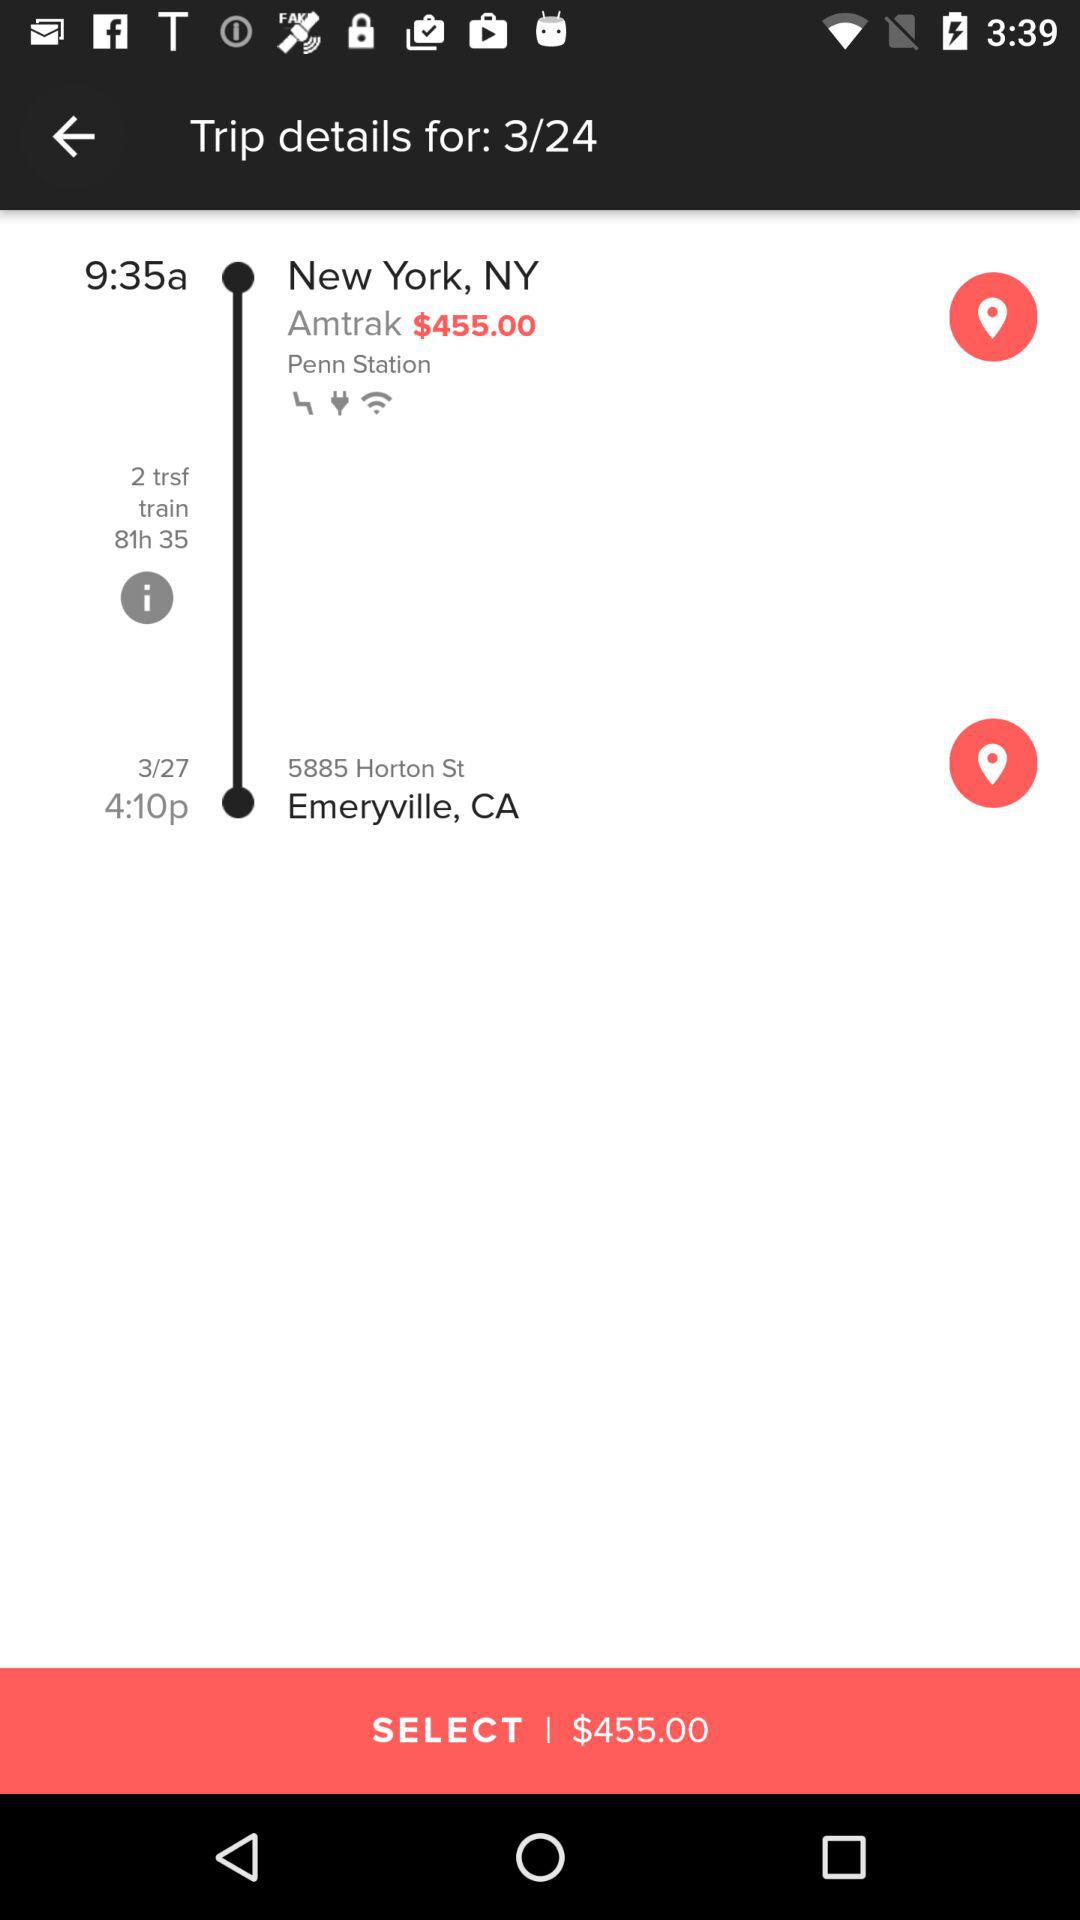Where is it from? It is from New York, NY. 